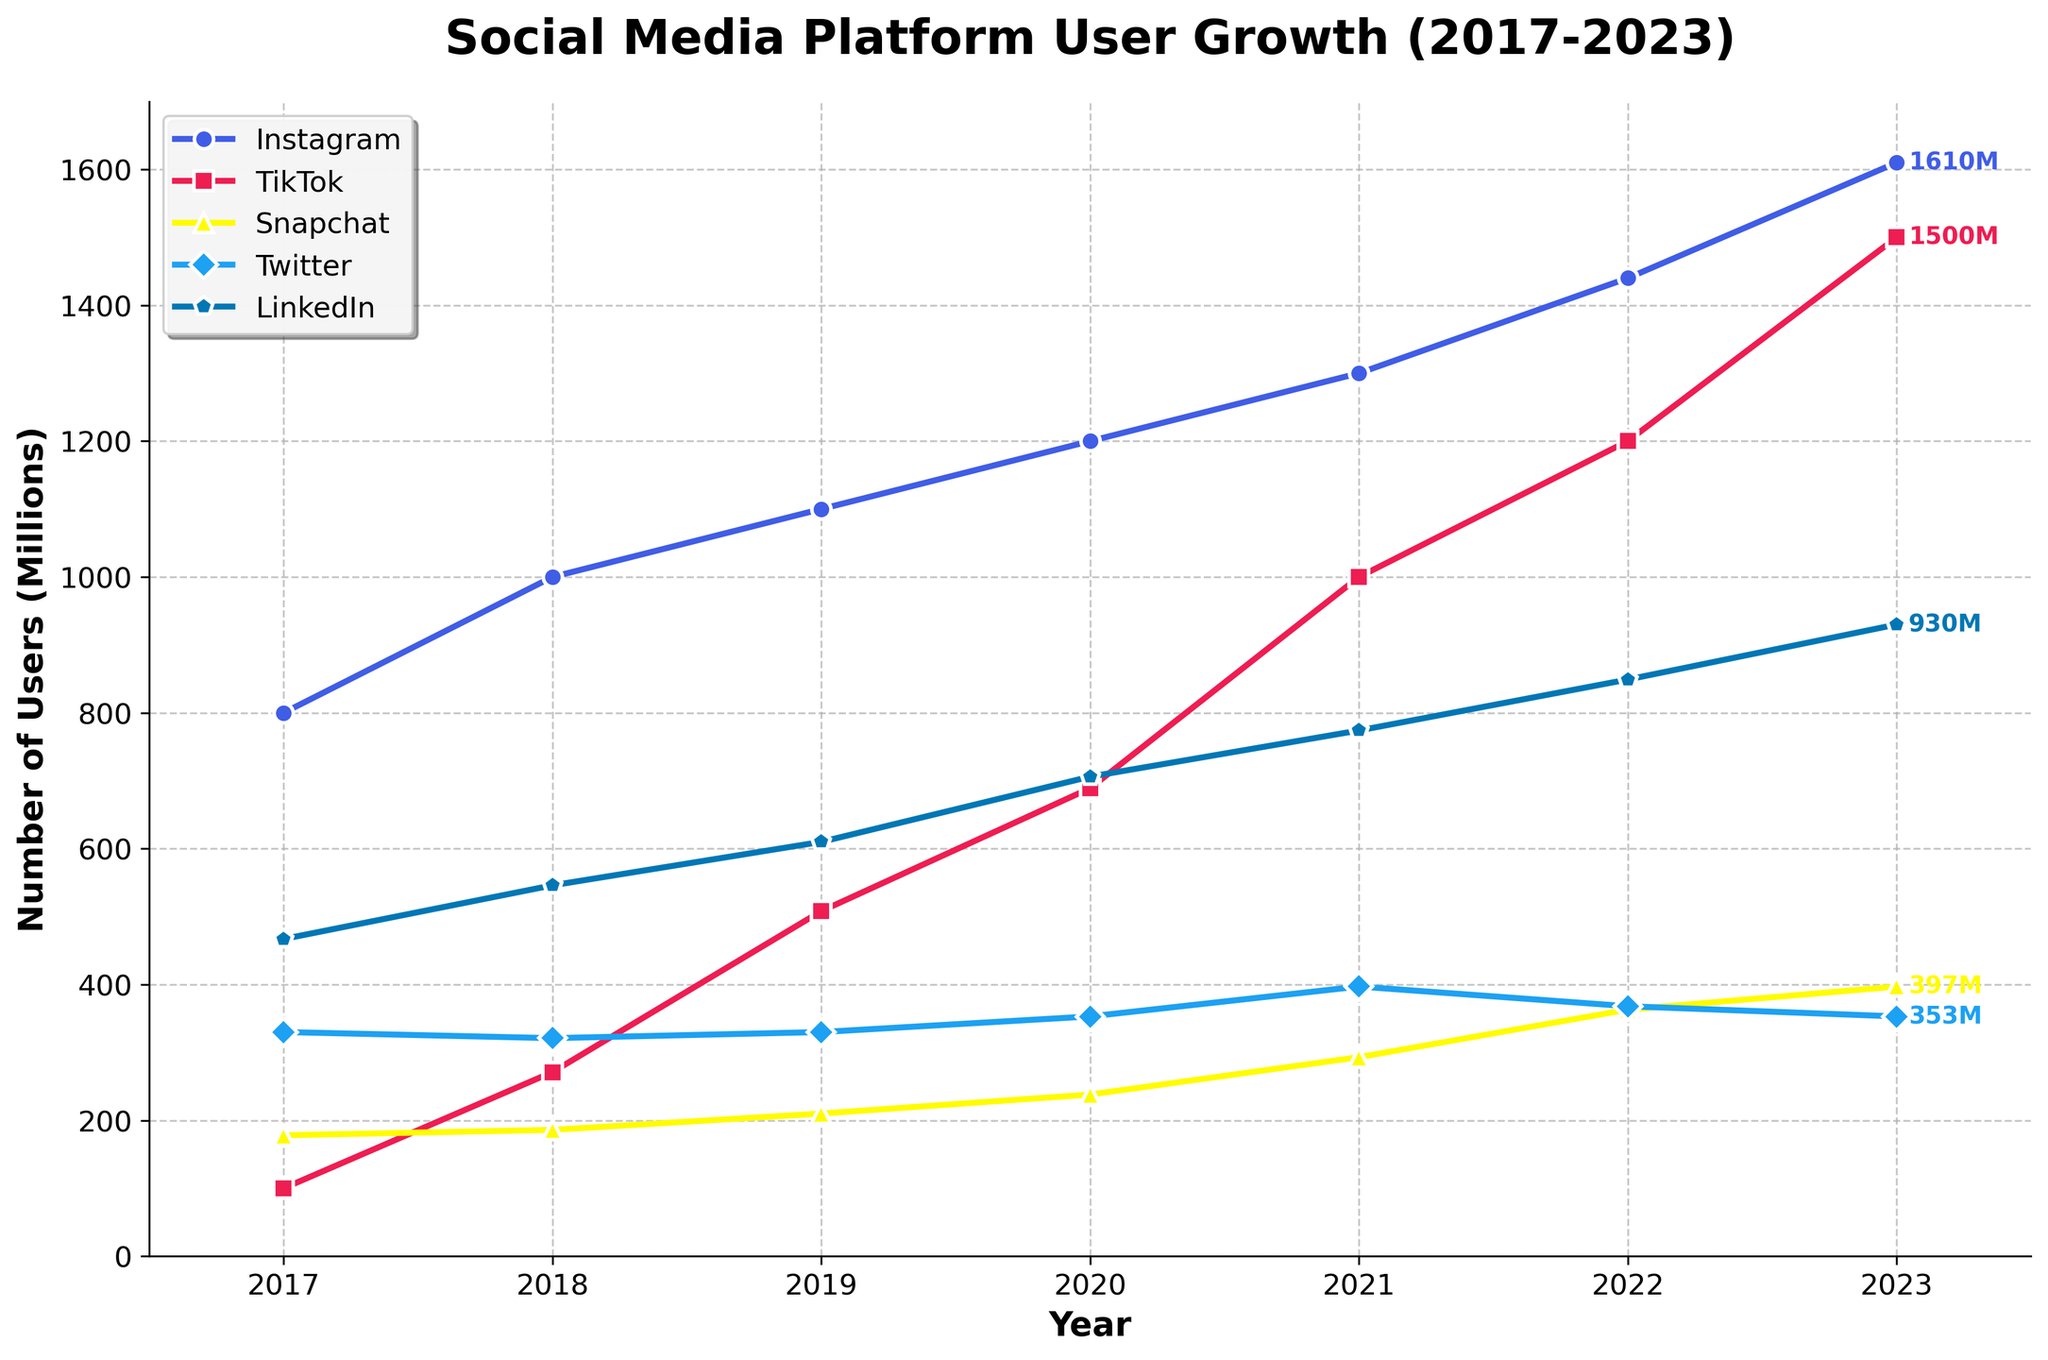What year did TikTok surpass Snapchat in user numbers? TikTok surpassed Snapchat when its number of users became higher than that of Snapchat. In 2019, TikTok had 508 million users, while Snapchat had 210 million users.
Answer: 2019 Which platform had the highest user growth between 2017 and 2023? Instagram grew from 800 million users in 2017 to 1610 million in 2023 (1610-800 = 810 million). TikTok grew from 100 million to 1500 million (1500-100 = 1400 million), Snapchat from 178 million to 397 million (397-178 = 219 million), Twitter from 330 million to 353 million (353-330 = 23 million), and LinkedIn from 467 million to 930 million (930-467 = 463 million).
Answer: TikTok How many total users did all platforms have in 2021? Add the number of users for all platforms in 2021: Instagram (1300) + TikTok (1000) + Snapchat (293) + Twitter (397) + LinkedIn (774). The total is 1300 + 1000 + 293 + 397 + 774 = 3764 million users.
Answer: 3764 million Which platform had the smallest increase in user numbers between 2020 and 2023? Calculate the difference in user numbers between 2020 and 2023 for each platform: Instagram (1610-1200 = 410), TikTok (1500-689 = 811), Snapchat (397-238 = 159), Twitter (353-353 = 0), and LinkedIn (930-706 = 224). Twitter had no increase in user numbers.
Answer: Twitter Which two platforms had the closest number of users in 2023? Compare the user numbers for all platforms in 2023: Instagram (1610), TikTok (1500), Snapchat (397), Twitter (353), and LinkedIn (930). The closest numbers are between Twitter (353) and Snapchat (397), with a difference of 44 million.
Answer: Twitter and Snapchat In which year did Snapchat have more users than Twitter for the first time? Compare the user numbers for Snapchat and Twitter over the years. In 2021, Snapchat had 293 million users while Twitter had 397 million, so by 2022, Snapchat had 363 million, which surpassed Twitter’s 368 million (not yet surpassing). By 2023, Snapchat had 397 million, while Twitter had 353 million.
Answer: 2023 What was the average number of LinkedIn users from 2017 to 2023? Add the number of LinkedIn users from 2017 to 2023 and divide by the number of years: (467 + 546 + 610 + 706 + 774 + 849 + 930) / 7 = 4882 / 7 ≈ 697.43 million.
Answer: 697.43 million Which platform saw a user decline between 2021 and 2023? Compare the user numbers between 2021 and 2023 for each platform: Instagram (1300 to 1610), TikTok (1000 to 1500), Snapchat (293 to 397), Twitter (397 to 353), LinkedIn (774 to 930). Twitter's users declined from 397 million in 2021 to 353 million in 2023.
Answer: Twitter By how much did TikTok's user base grow from 2018 to 2019? Subtract the number of TikTok users in 2018 from the number in 2019: 508 - 271 = 237 million.
Answer: 237 million 